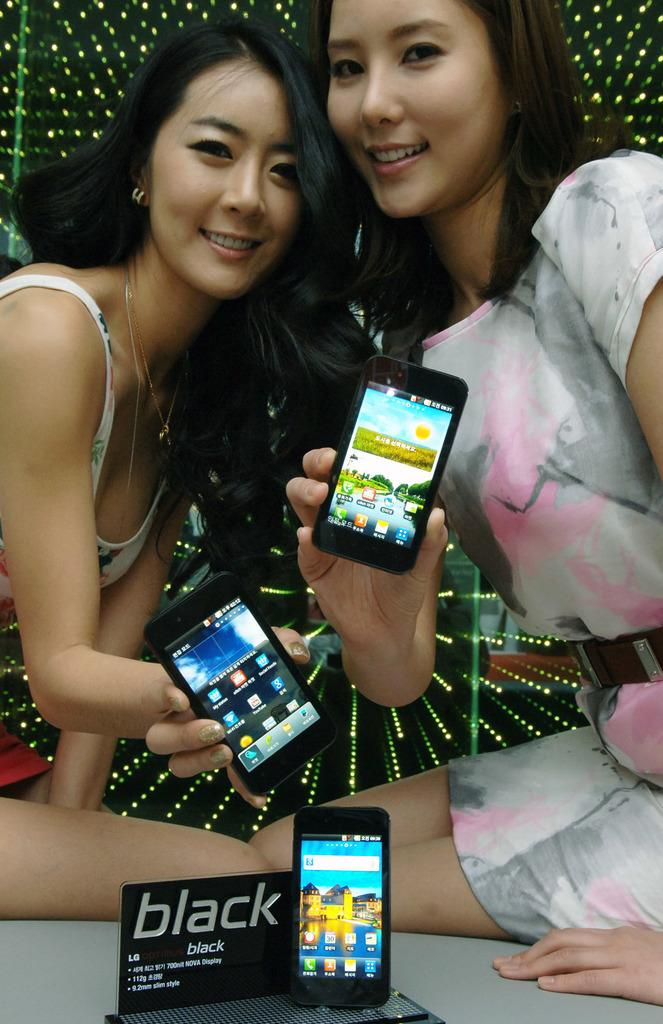Provide a one-sentence caption for the provided image. Two young ladies hold up phones near a BLACK display sign. 